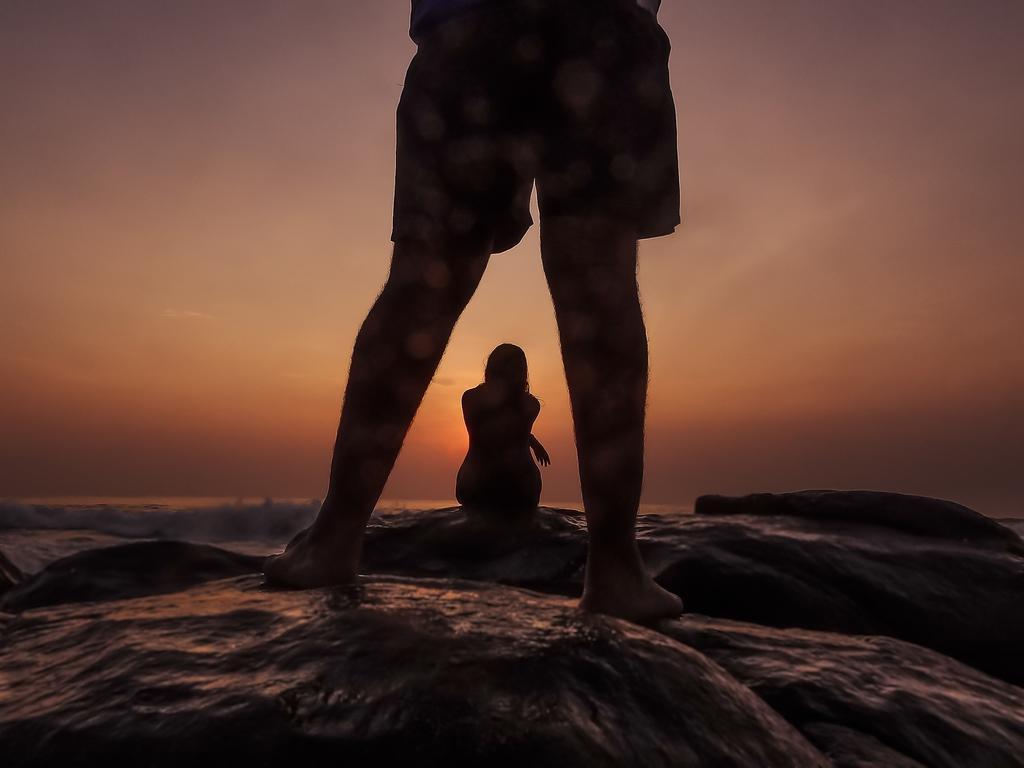Please provide a concise description of this image. In this image we can see a person's legs on the rocks. In the background we can see a girl is sitting on the rock, water and clouds in the sky. 